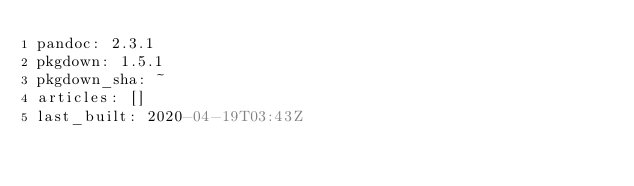Convert code to text. <code><loc_0><loc_0><loc_500><loc_500><_YAML_>pandoc: 2.3.1
pkgdown: 1.5.1
pkgdown_sha: ~
articles: []
last_built: 2020-04-19T03:43Z

</code> 